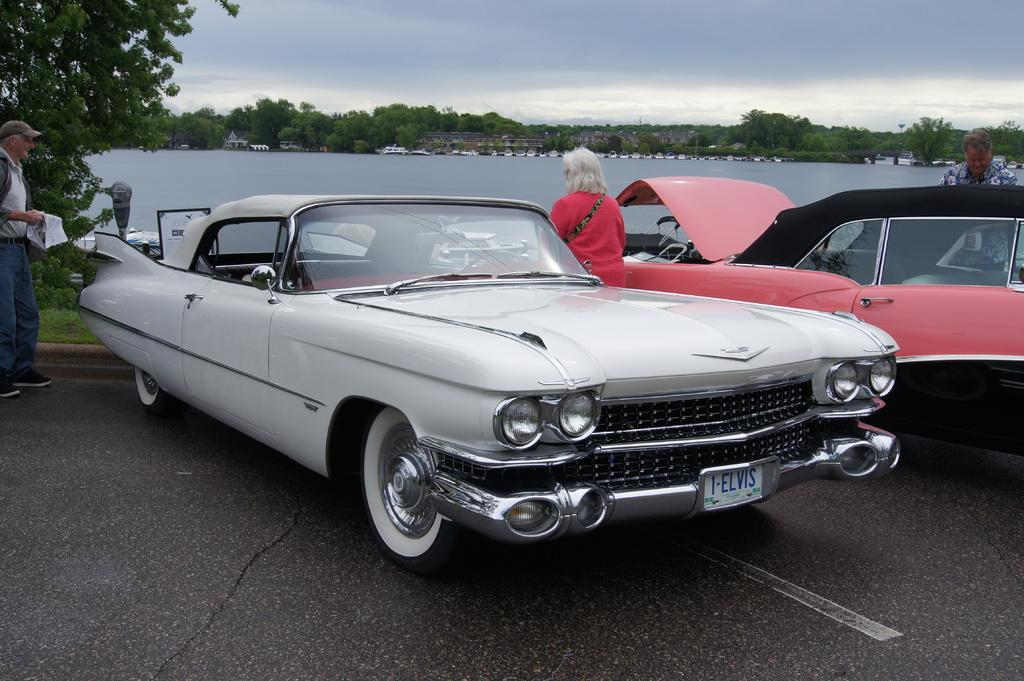What is located on the left side of the image? There is a man on the left side of the image. What is the man wearing on his head? The man is wearing a cap. What can be seen in the middle of the image? There is a car on the road in the middle of the image. What is visible in the image besides the man and the car? There is water and green trees visible in the image. What color is the blood on the man's finger in the image? There is no blood or finger present in the image. 